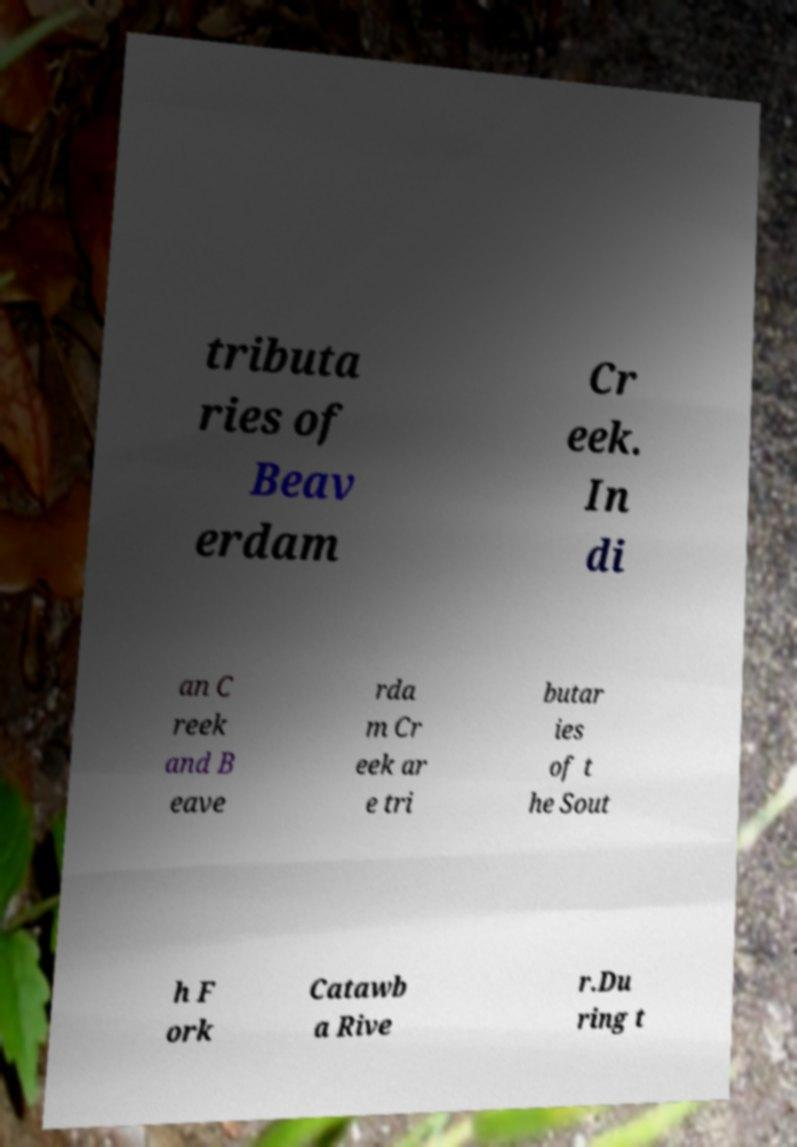Can you accurately transcribe the text from the provided image for me? tributa ries of Beav erdam Cr eek. In di an C reek and B eave rda m Cr eek ar e tri butar ies of t he Sout h F ork Catawb a Rive r.Du ring t 